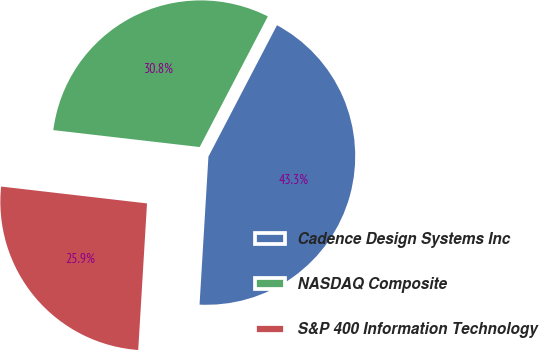Convert chart to OTSL. <chart><loc_0><loc_0><loc_500><loc_500><pie_chart><fcel>Cadence Design Systems Inc<fcel>NASDAQ Composite<fcel>S&P 400 Information Technology<nl><fcel>43.3%<fcel>30.82%<fcel>25.88%<nl></chart> 